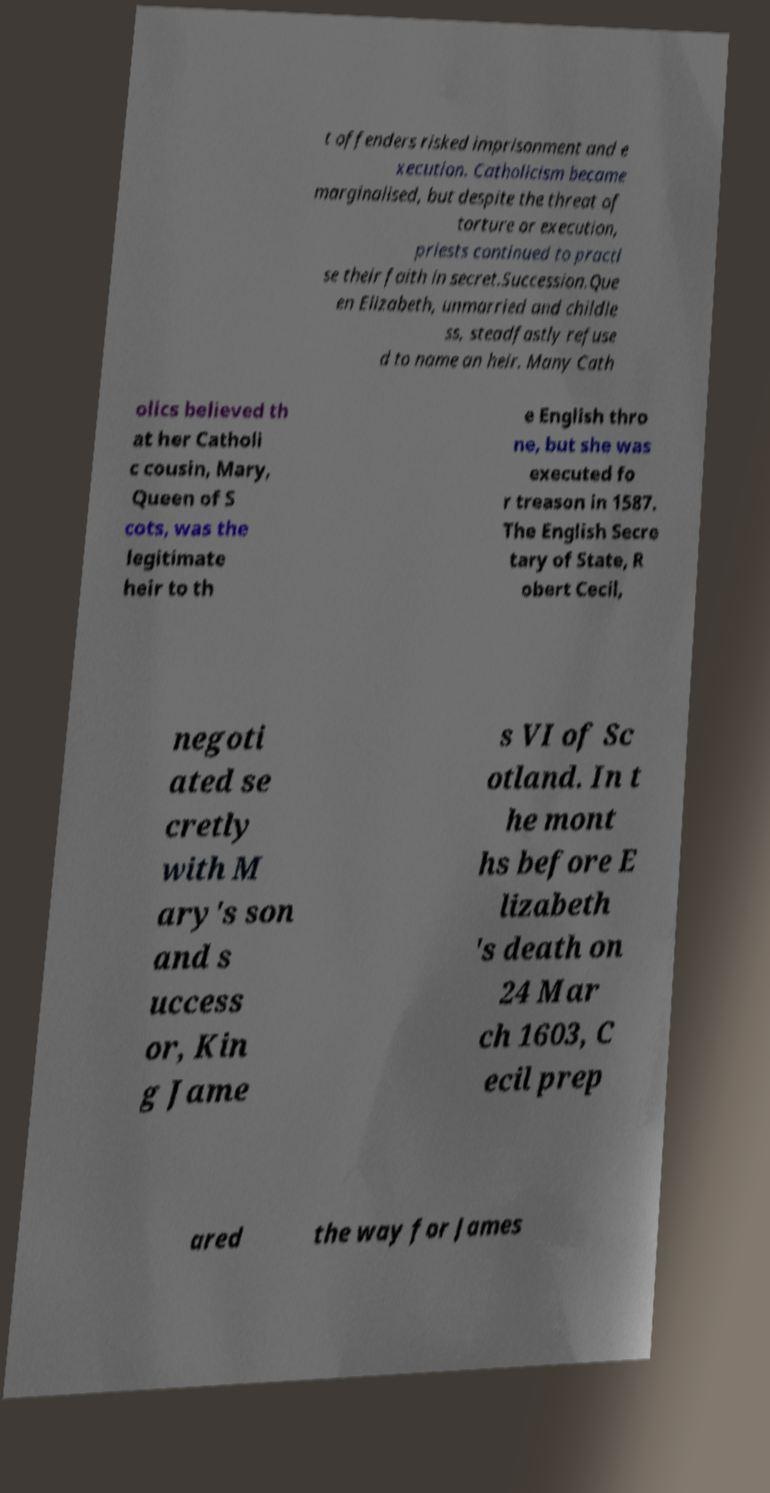Can you read and provide the text displayed in the image?This photo seems to have some interesting text. Can you extract and type it out for me? t offenders risked imprisonment and e xecution. Catholicism became marginalised, but despite the threat of torture or execution, priests continued to practi se their faith in secret.Succession.Que en Elizabeth, unmarried and childle ss, steadfastly refuse d to name an heir. Many Cath olics believed th at her Catholi c cousin, Mary, Queen of S cots, was the legitimate heir to th e English thro ne, but she was executed fo r treason in 1587. The English Secre tary of State, R obert Cecil, negoti ated se cretly with M ary's son and s uccess or, Kin g Jame s VI of Sc otland. In t he mont hs before E lizabeth 's death on 24 Mar ch 1603, C ecil prep ared the way for James 